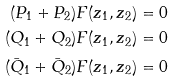Convert formula to latex. <formula><loc_0><loc_0><loc_500><loc_500>( P _ { 1 } + P _ { 2 } ) F ( z _ { 1 } , z _ { 2 } ) = 0 \\ ( Q _ { 1 } + Q _ { 2 } ) F ( z _ { 1 } , z _ { 2 } ) = 0 \\ ( \bar { Q } _ { 1 } + \bar { Q } _ { 2 } ) F ( z _ { 1 } , z _ { 2 } ) = 0</formula> 